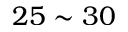<formula> <loc_0><loc_0><loc_500><loc_500>2 5 \sim 3 0</formula> 